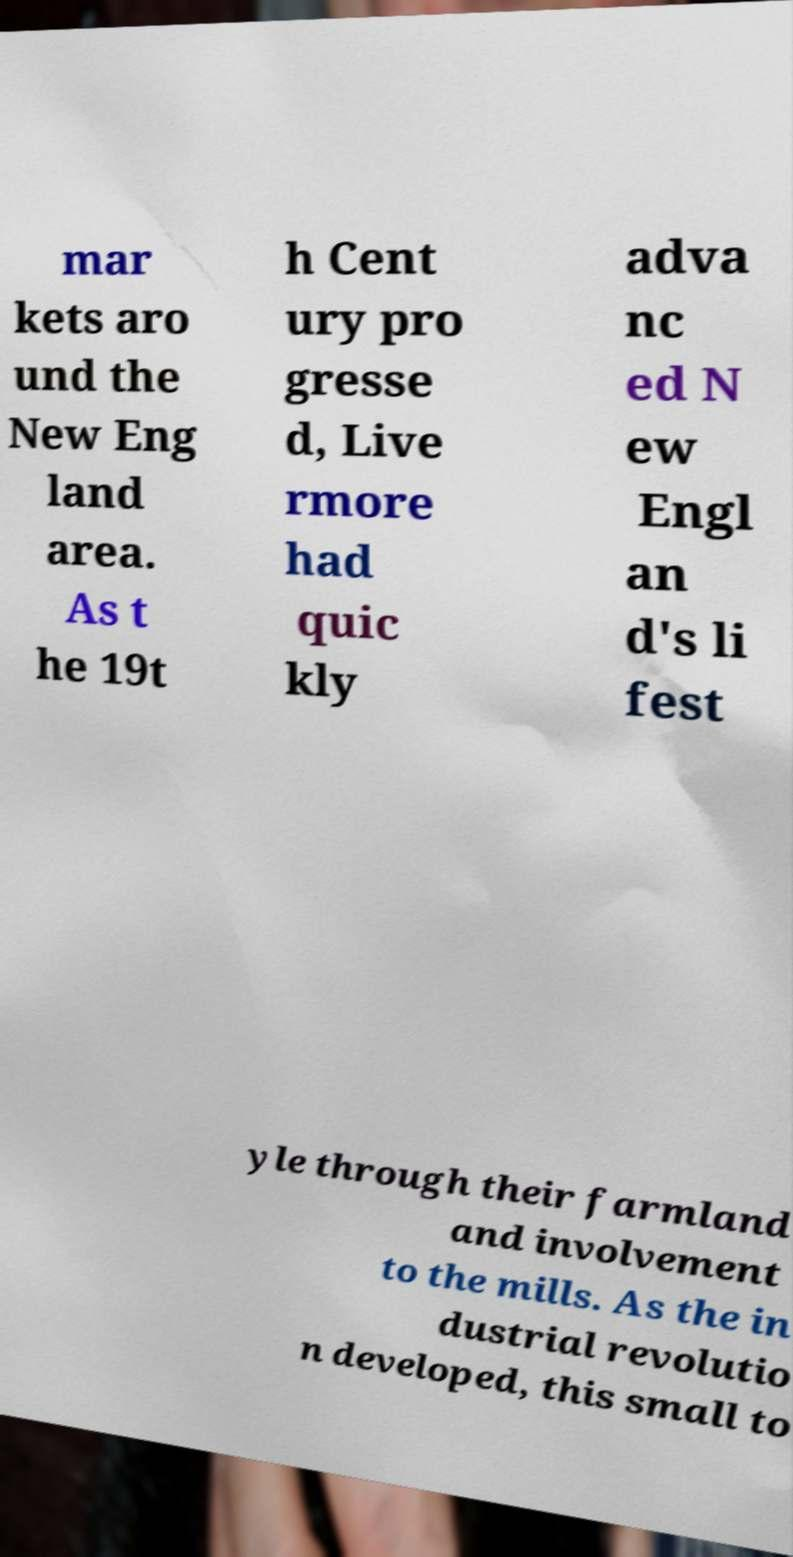Please read and relay the text visible in this image. What does it say? mar kets aro und the New Eng land area. As t he 19t h Cent ury pro gresse d, Live rmore had quic kly adva nc ed N ew Engl an d's li fest yle through their farmland and involvement to the mills. As the in dustrial revolutio n developed, this small to 